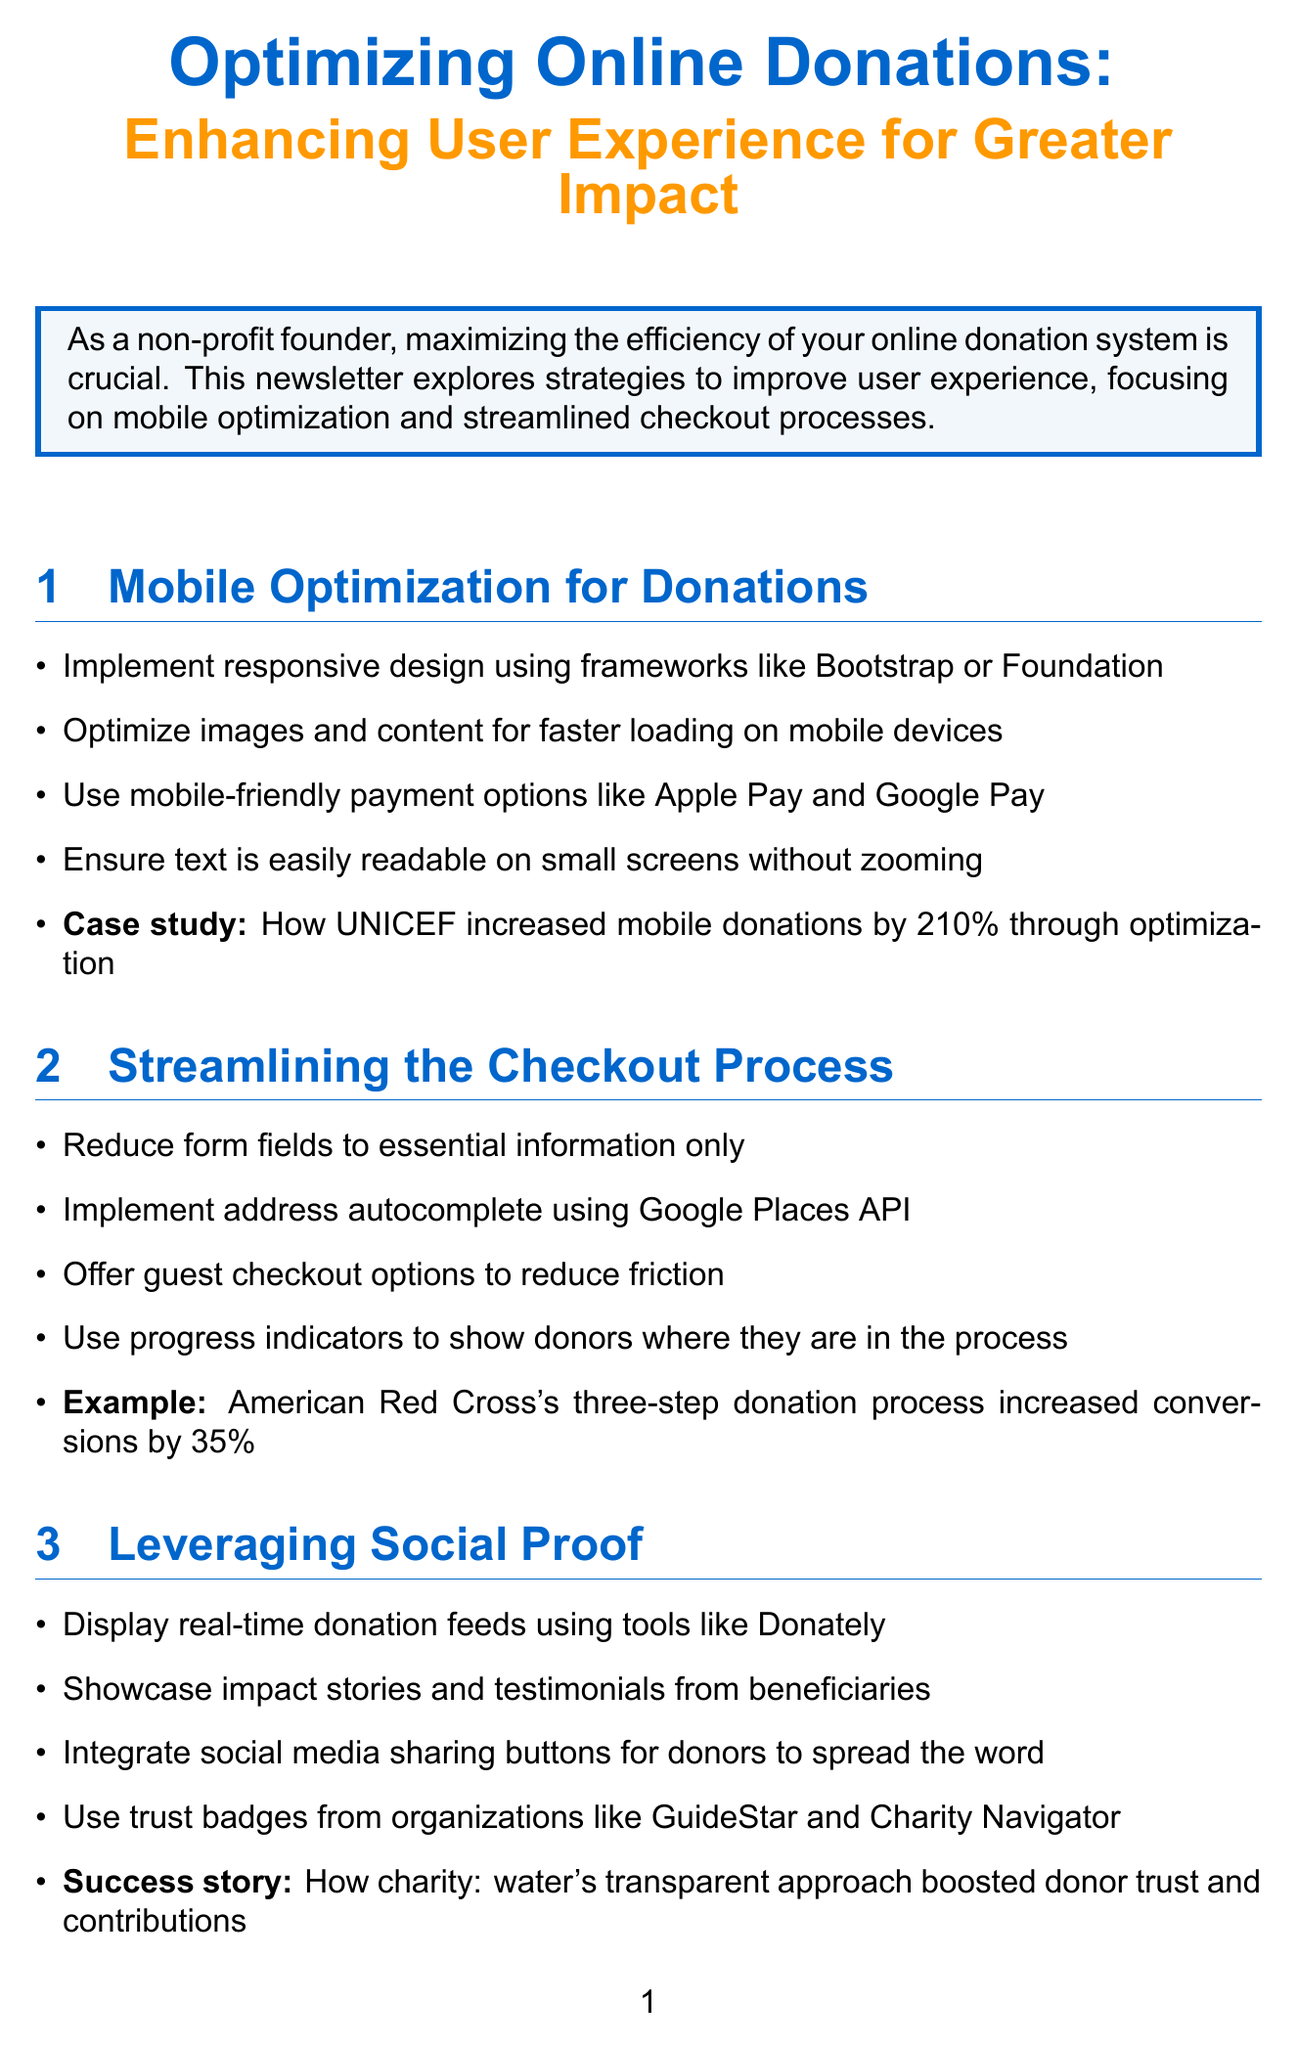What is the title of the newsletter? The title of the newsletter is usually prominently displayed at the top of the document.
Answer: Optimizing Online Donations: Enhancing User Experience for Greater Impact What framework is suggested for responsive design? The document lists specific frameworks that are useful for implementing responsive design in mobile optimization.
Answer: Bootstrap or Foundation By what percentage did UNICEF increase mobile donations? This statistic is given as an example in the case study under mobile optimization.
Answer: 210% What are the essential features recommended for streamlining the checkout process? The document discusses reducing form fields to essential information only as a key feature for improving the checkout process.
Answer: Essential information only What is a recommended tool for real-time donation feeds? The newsletter provides specific tools that can display real-time donation information.
Answer: Donately Which organization increased conversions by 35% through a three-step donation process? This example is provided to illustrate the impact of streamlined checkout processes.
Answer: American Red Cross What do personalized thank-you messages enhance? The document highlights the role of personalized messages in improving donor experience, which is a central theme in the personalization section.
Answer: Donor satisfaction What type of compliance is mentioned for handling credit card information? This aspect is critical for ensuring secure transactions according to the technical recommendations.
Answer: PCI DSS compliance What should non-profits do to contact for a consultation? The document ends with a call to action encouraging readers to take further steps.
Answer: Contact our team 